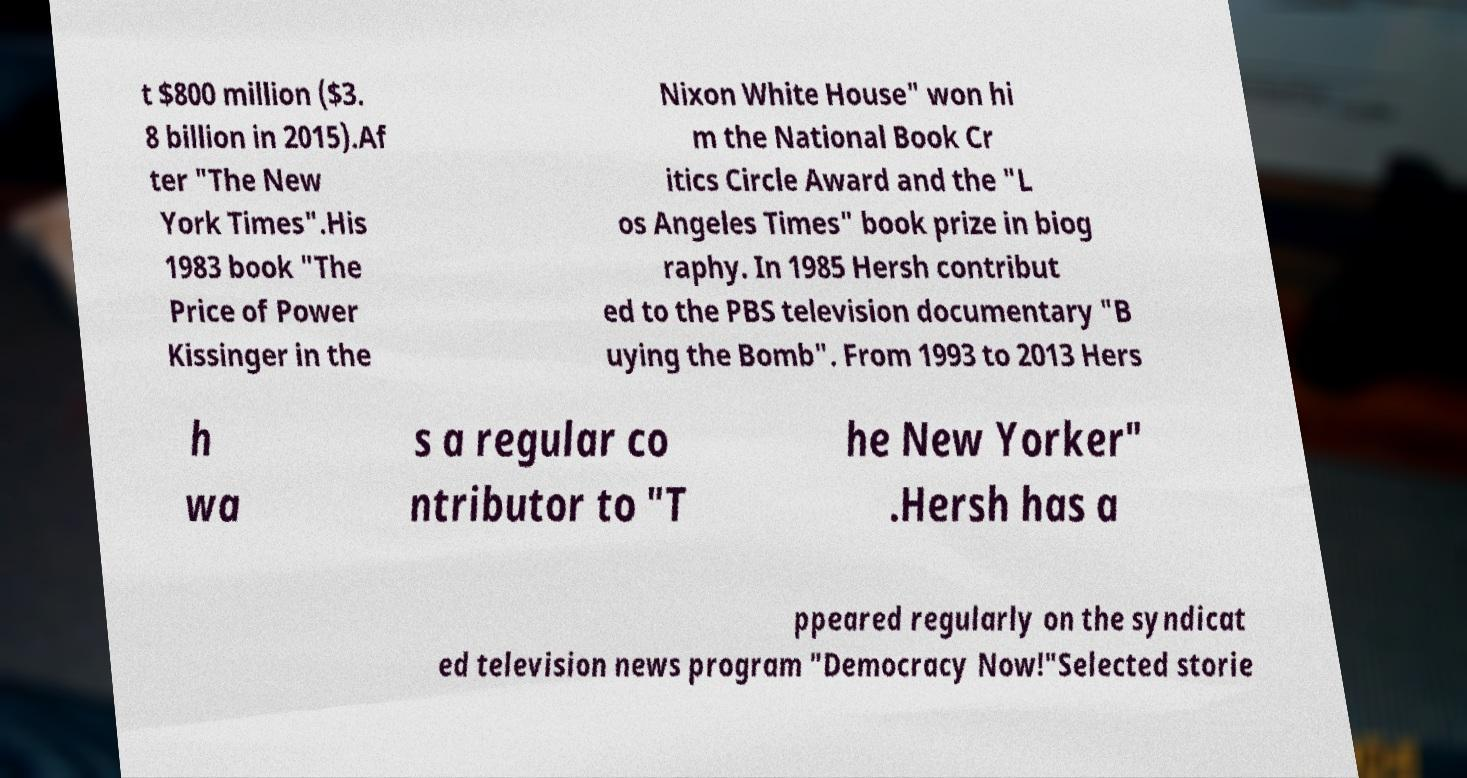For documentation purposes, I need the text within this image transcribed. Could you provide that? t $800 million ($3. 8 billion in 2015).Af ter "The New York Times".His 1983 book "The Price of Power Kissinger in the Nixon White House" won hi m the National Book Cr itics Circle Award and the "L os Angeles Times" book prize in biog raphy. In 1985 Hersh contribut ed to the PBS television documentary "B uying the Bomb". From 1993 to 2013 Hers h wa s a regular co ntributor to "T he New Yorker" .Hersh has a ppeared regularly on the syndicat ed television news program "Democracy Now!"Selected storie 